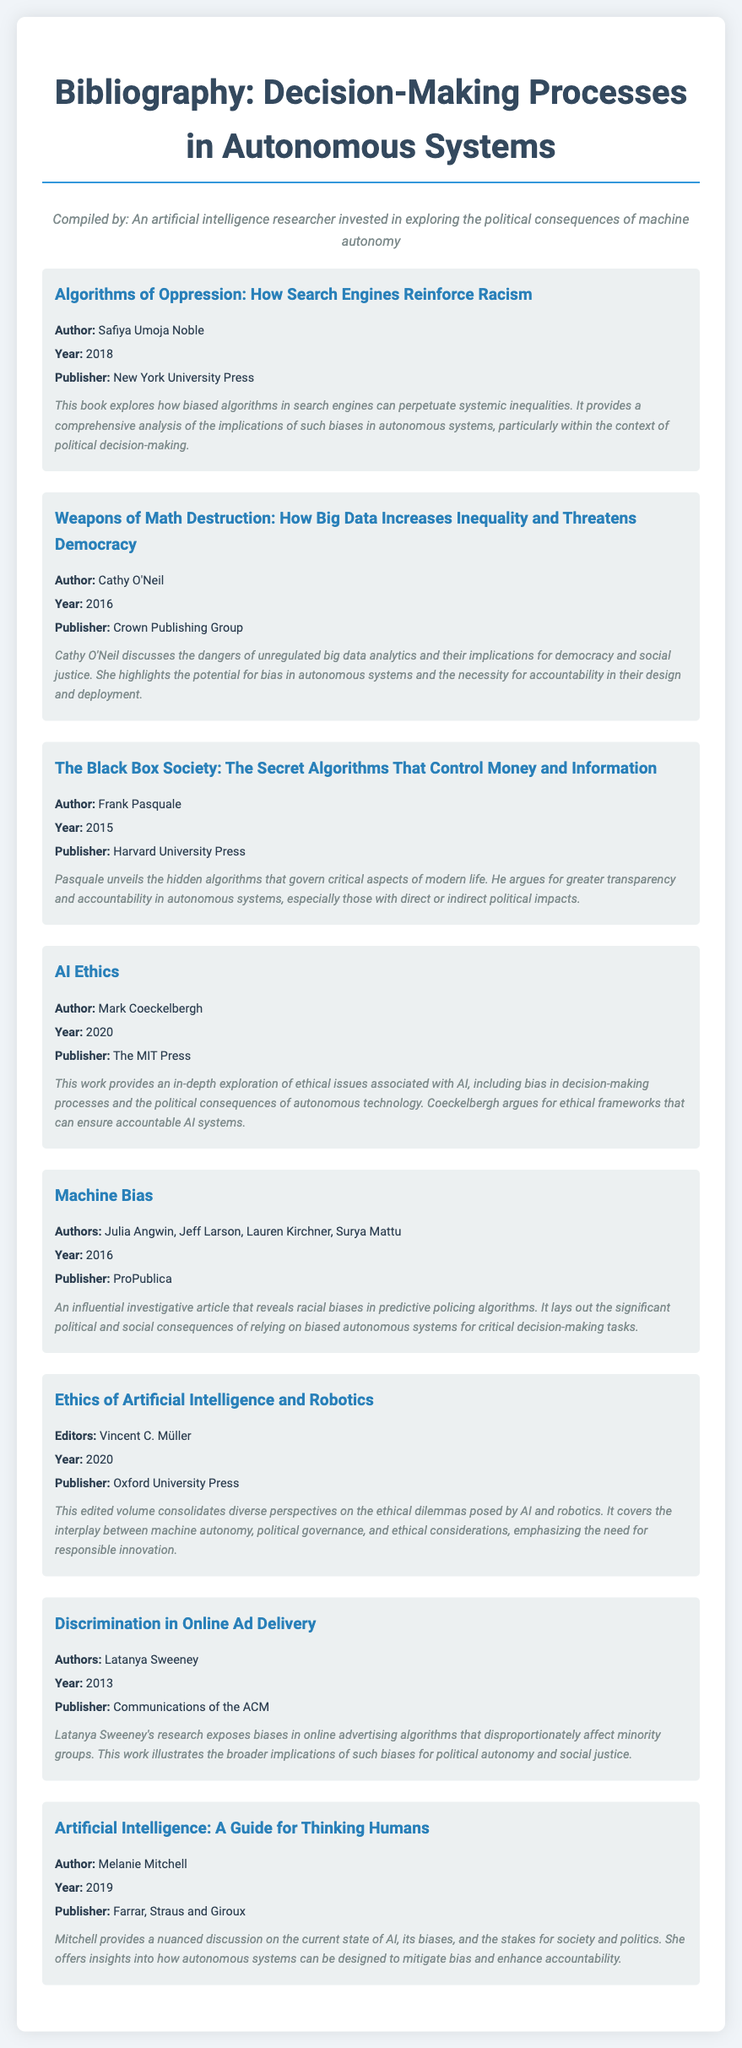What is the title of the first entry? The title of the first entry is the name of the work listed in the bibliography, which is the first piece presented in the document.
Answer: Algorithms of Oppression: How Search Engines Reinforce Racism Who is the author of "Ethics of Artificial Intelligence and Robotics"? The author information is presented in each entry, showing the contributors to the respective work. For this entry, it's mentioned at the top of its description.
Answer: Vincent C. Müller What year was "Weapons of Math Destruction" published? The year of publication is specified for each bibliography entry, indicating when the work was released to the public, allowing for insights into its relevance over time.
Answer: 2016 How many entries have a publication year after 2017? By counting through the years provided in the document for each work, we can establish how many are recent and thus relevant to current discussions.
Answer: 4 What common theme is addressed by "Machine Bias" and "Algorithms of Oppression"? The themes are highlighted in the summaries of the entries, revealing the broader connections in their discussions regarding societal implications of algorithms.
Answer: Bias Which publisher released "AI Ethics"? The publisher details are listed for each entry, specifying who made the work available, which can be important for understanding its academic backing.
Answer: The MIT Press What is the summary focus of "The Black Box Society"? The summaries articulate the main messages or conclusions of each work, providing insight into their key arguments and relevance to the topic of machine autonomy.
Answer: Transparency and accountability In which entry is discrimination in online advertising discussed? Each entry provides a title with its specific focus, allowing readers to identify where particular issues are explored within the bibliography.
Answer: Discrimination in Online Ad Delivery What type of document is this? An overview of the document's structure is provided through its layout and content, making it evident what category it belongs to.
Answer: Bibliography 